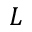<formula> <loc_0><loc_0><loc_500><loc_500>L</formula> 